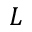<formula> <loc_0><loc_0><loc_500><loc_500>L</formula> 